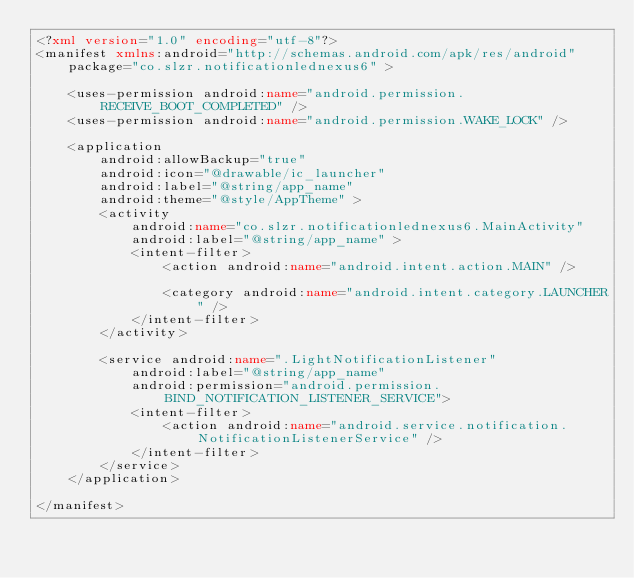Convert code to text. <code><loc_0><loc_0><loc_500><loc_500><_XML_><?xml version="1.0" encoding="utf-8"?>
<manifest xmlns:android="http://schemas.android.com/apk/res/android"
    package="co.slzr.notificationlednexus6" >

    <uses-permission android:name="android.permission.RECEIVE_BOOT_COMPLETED" />
    <uses-permission android:name="android.permission.WAKE_LOCK" />

    <application
        android:allowBackup="true"
        android:icon="@drawable/ic_launcher"
        android:label="@string/app_name"
        android:theme="@style/AppTheme" >
        <activity
            android:name="co.slzr.notificationlednexus6.MainActivity"
            android:label="@string/app_name" >
            <intent-filter>
                <action android:name="android.intent.action.MAIN" />

                <category android:name="android.intent.category.LAUNCHER" />
            </intent-filter>
        </activity>

        <service android:name=".LightNotificationListener"
            android:label="@string/app_name"
            android:permission="android.permission.BIND_NOTIFICATION_LISTENER_SERVICE">
            <intent-filter>
                <action android:name="android.service.notification.NotificationListenerService" />
            </intent-filter>
        </service>
    </application>

</manifest>
</code> 